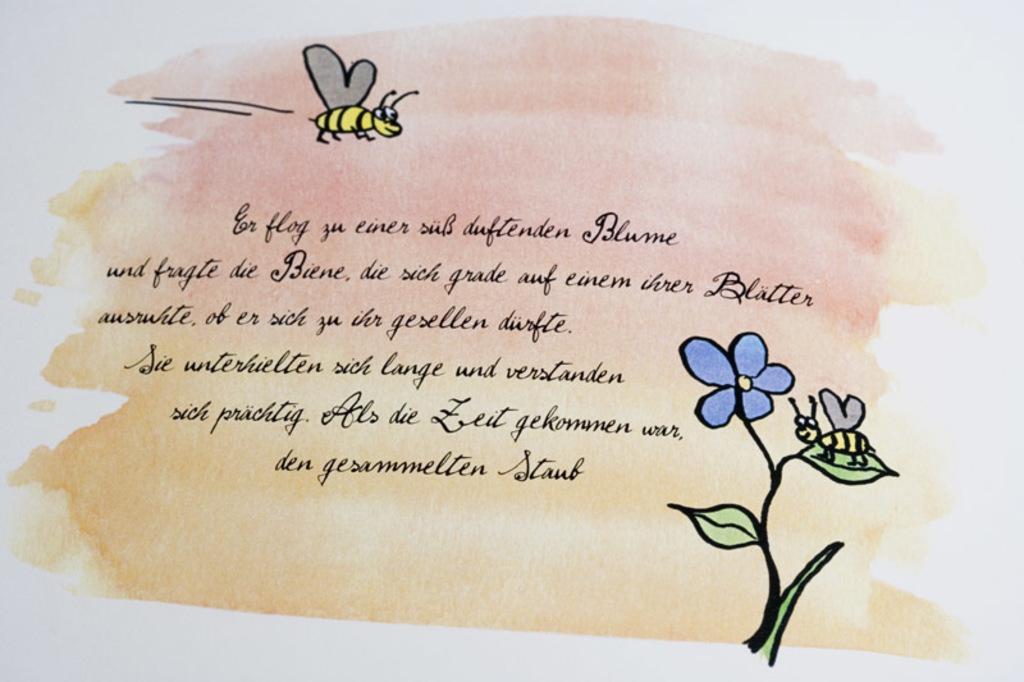In one or two sentences, can you explain what this image depicts? In this picture, it looks like a paper and on the paper there are drawings of insects, a flower and leaves. On the paper it is written something. 